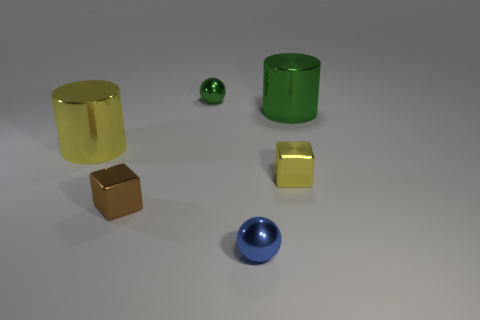What is the shape of the yellow thing in front of the large shiny cylinder left of the brown shiny object?
Keep it short and to the point. Cube. Are there any other things that are the same shape as the tiny brown metal object?
Ensure brevity in your answer.  Yes. Is the number of large green objects in front of the large yellow metal cylinder greater than the number of brown rubber things?
Offer a very short reply. No. How many balls are in front of the big green cylinder that is behind the yellow metal cube?
Give a very brief answer. 1. There is a big object that is to the left of the small shiny ball in front of the small yellow block to the right of the small green ball; what shape is it?
Your answer should be compact. Cylinder. The green sphere is what size?
Your response must be concise. Small. Are there any tiny blocks that have the same material as the tiny yellow object?
Offer a very short reply. Yes. What is the size of the green object that is the same shape as the small blue shiny thing?
Your answer should be compact. Small. Are there an equal number of blue shiny balls that are on the right side of the big green metal thing and blue balls?
Offer a terse response. No. Does the green object that is behind the green metallic cylinder have the same shape as the tiny brown shiny object?
Ensure brevity in your answer.  No. 